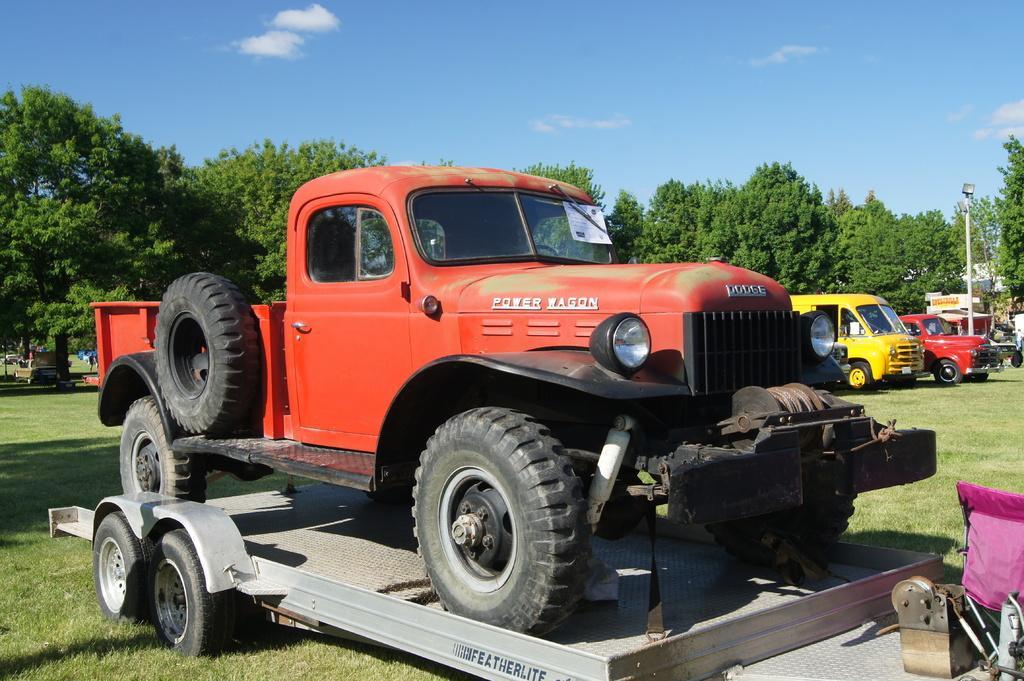In one or two sentences, can you explain what this image depicts? In the center of the image we can see one red vehicle on the other vehicle and we can see tools and a few other objects. In the background, we can see the sky, clouds, trees, grass, vehicles, one pole, one banner etc. 